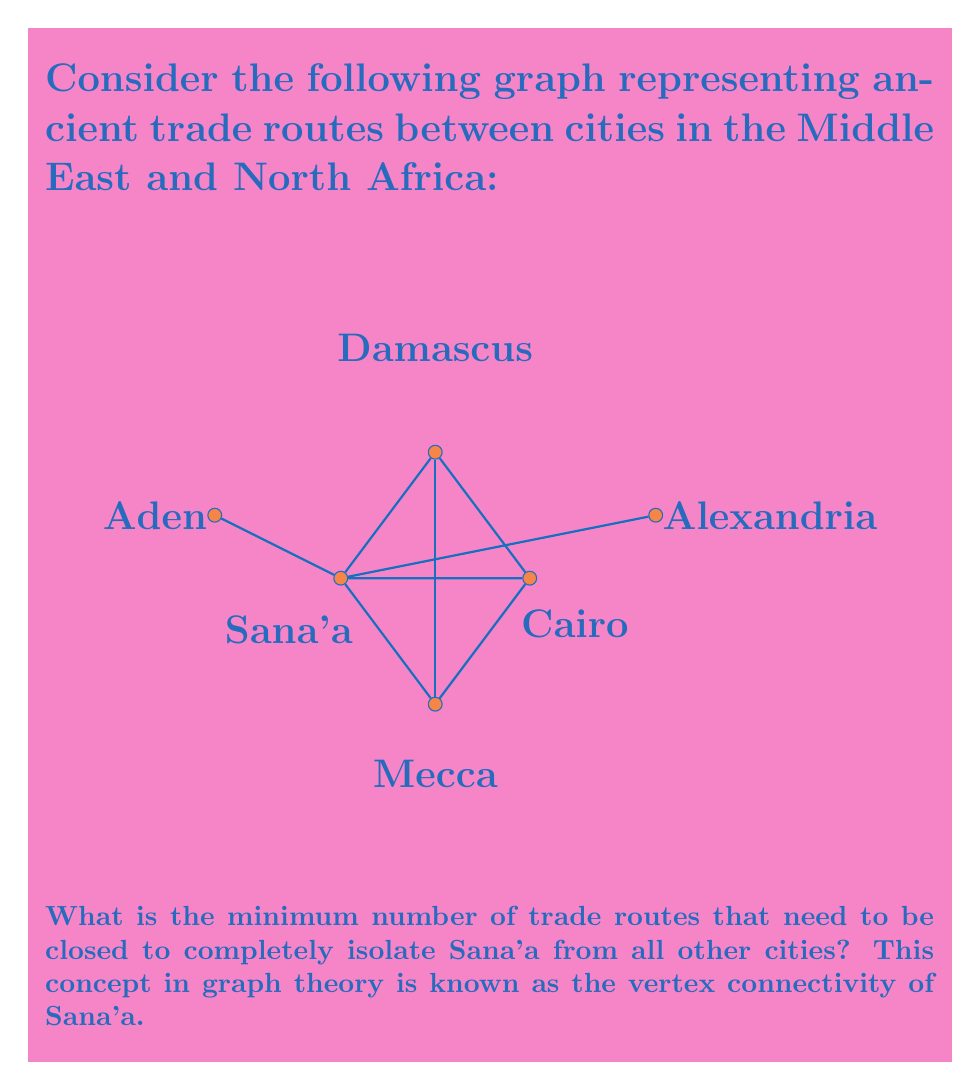Teach me how to tackle this problem. To solve this problem, we need to understand the concept of vertex connectivity in graph theory. The vertex connectivity of a node is the minimum number of vertices that need to be removed to disconnect that node from the rest of the graph.

Let's approach this step-by-step:

1) First, we identify all paths from Sana'a to other cities:
   - Sana'a - Cairo
   - Sana'a - Damascus
   - Sana'a - Mecca
   - Sana'a - Aden
   - Sana'a - Alexandria

2) We need to find the minimum number of vertices that, when removed, will disconnect all these paths.

3) Observe that Sana'a is directly connected to four cities: Cairo, Damascus, Mecca, and Aden.

4) The connection to Alexandria is through Cairo.

5) To isolate Sana'a, we need to remove all its direct connections.

6) Therefore, we need to remove 4 vertices: Cairo, Damascus, Mecca, and Aden.

7) After removing these 4 vertices, Sana'a will be completely isolated from the rest of the graph.

Thus, the vertex connectivity of Sana'a in this graph is 4.
Answer: 4 